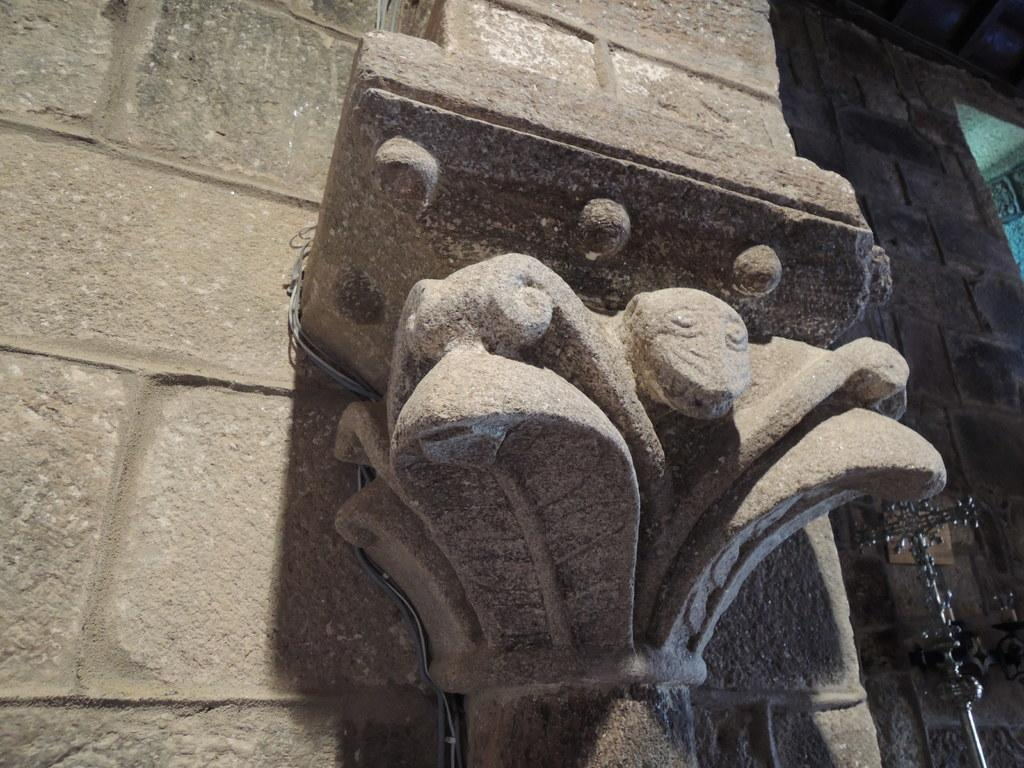What is the main structure visible in the image? There is a pillar in the image. What can be seen in the background of the image? There is a wall in the background of the image. What is located on the right side of the image? There is an unspecified object on the right side of the image. How many cobwebs can be seen hanging from the pillar in the image? There is no mention of cobwebs in the image, so it is not possible to determine their presence or quantity. What type of chairs are placed around the pillar in the image? There is no mention of chairs in the image, so it is not possible to describe their presence or type. 